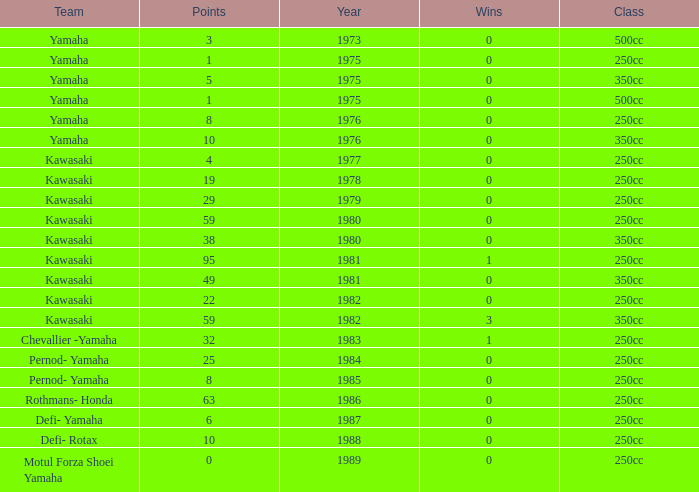Which highest wins number had Kawasaki as a team, 95 points, and a year prior to 1981? None. 